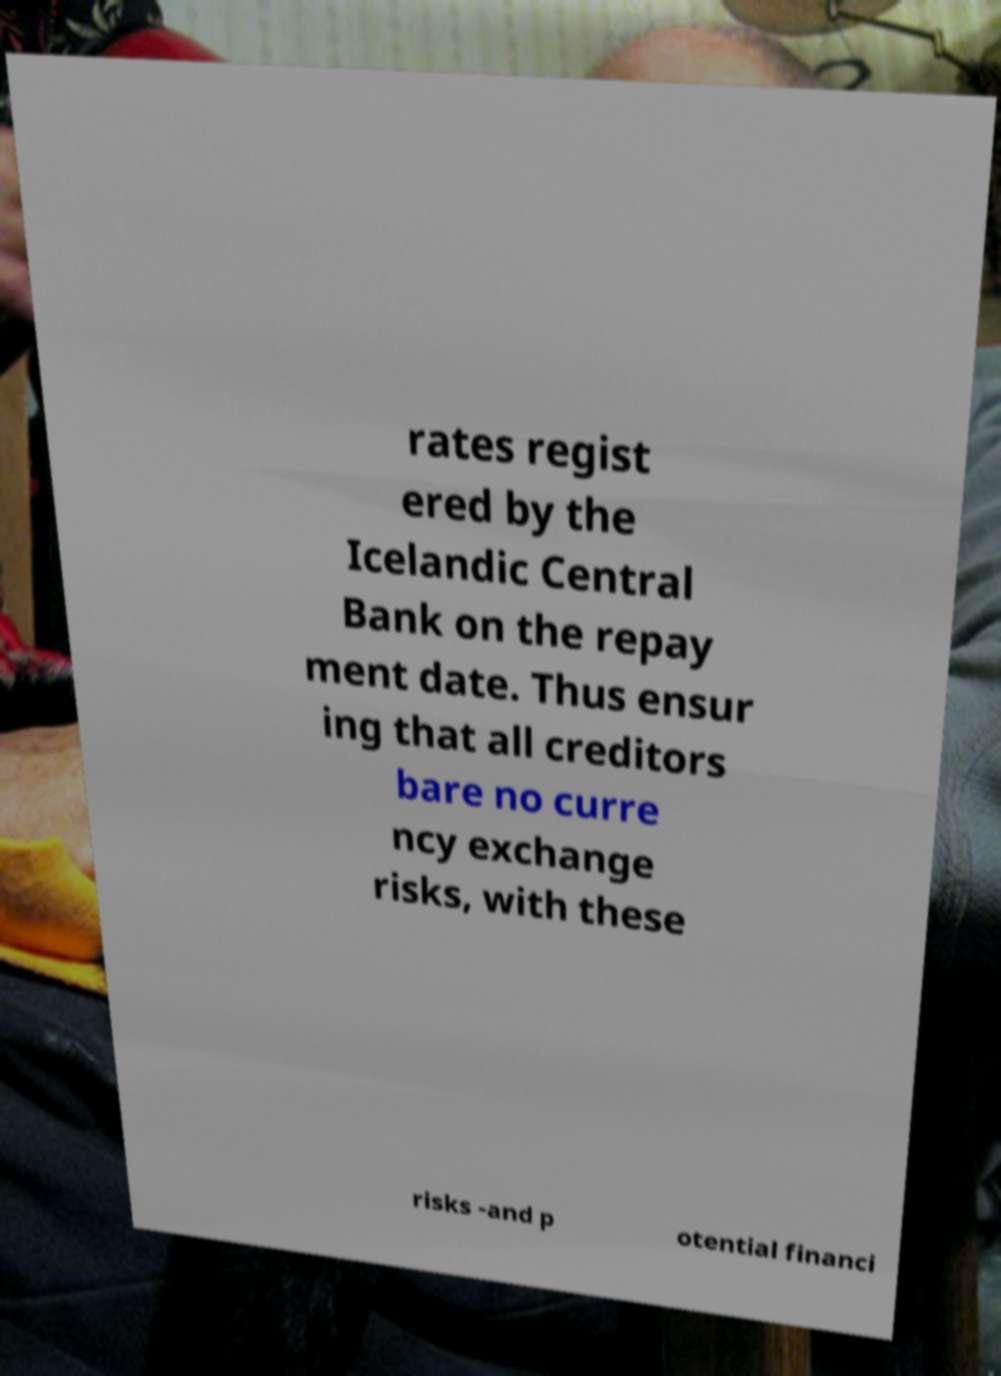Could you extract and type out the text from this image? rates regist ered by the Icelandic Central Bank on the repay ment date. Thus ensur ing that all creditors bare no curre ncy exchange risks, with these risks -and p otential financi 